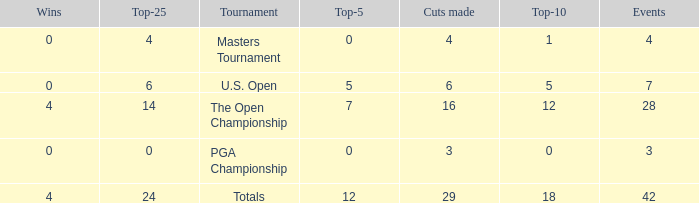What are the highest wins with cuts smaller than 6, events of 4 and a top-5 smaller than 0? None. 